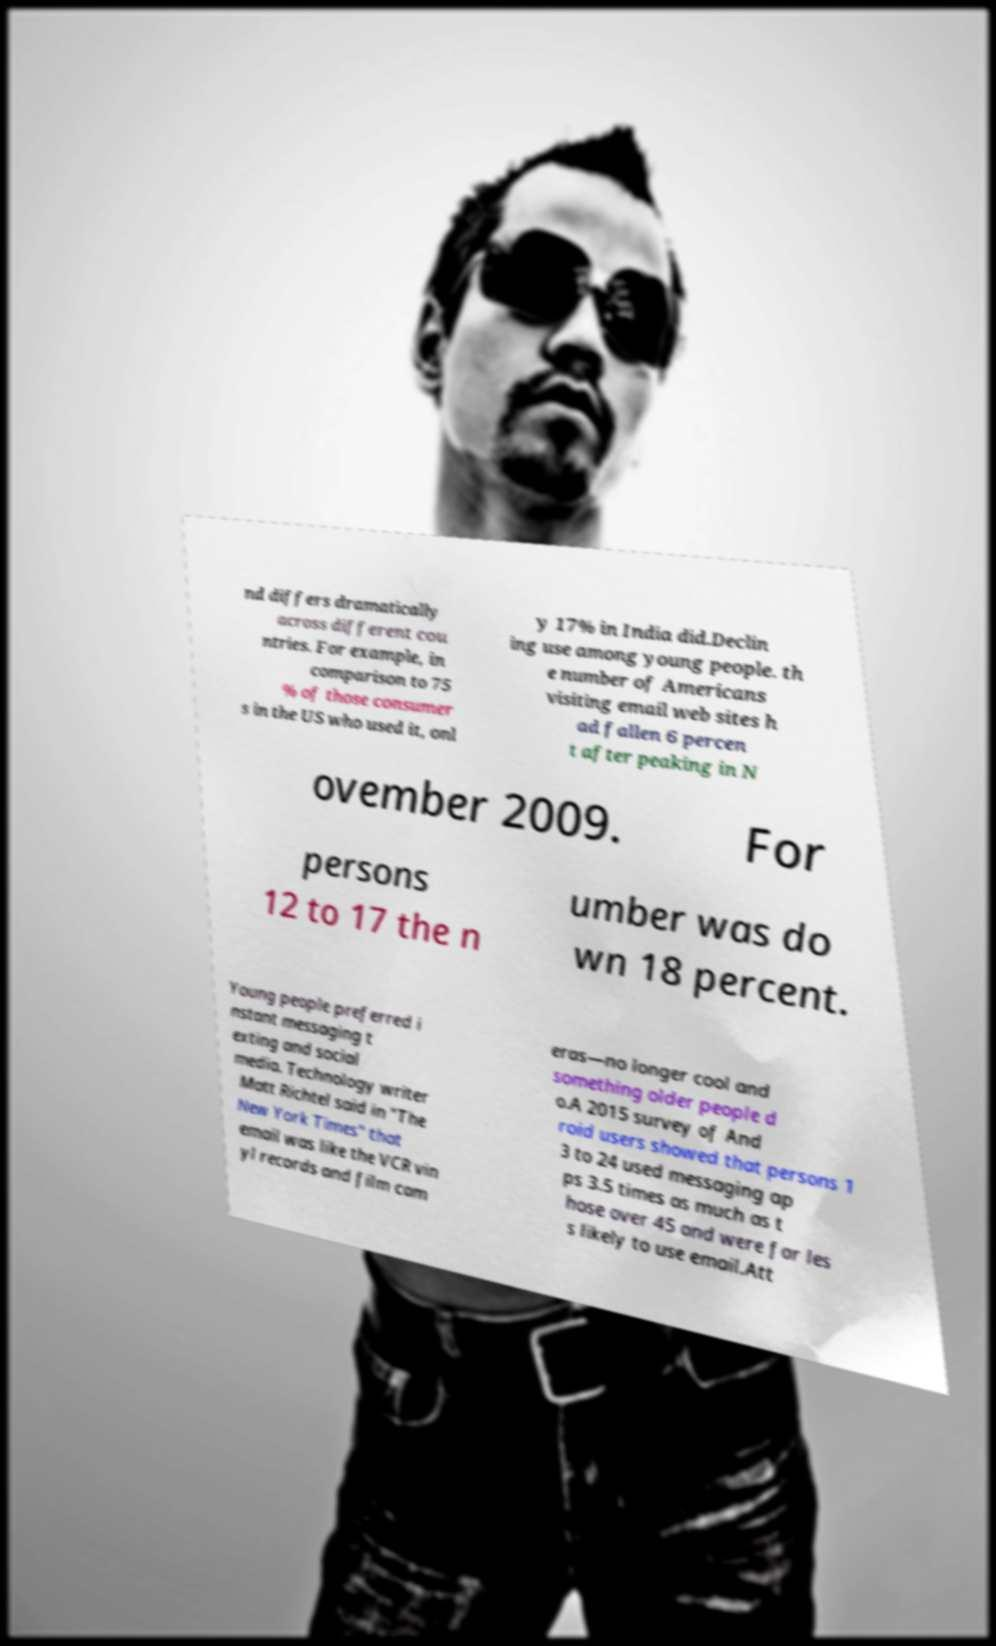Can you read and provide the text displayed in the image?This photo seems to have some interesting text. Can you extract and type it out for me? nd differs dramatically across different cou ntries. For example, in comparison to 75 % of those consumer s in the US who used it, onl y 17% in India did.Declin ing use among young people. th e number of Americans visiting email web sites h ad fallen 6 percen t after peaking in N ovember 2009. For persons 12 to 17 the n umber was do wn 18 percent. Young people preferred i nstant messaging t exting and social media. Technology writer Matt Richtel said in "The New York Times" that email was like the VCR vin yl records and film cam eras—no longer cool and something older people d o.A 2015 survey of And roid users showed that persons 1 3 to 24 used messaging ap ps 3.5 times as much as t hose over 45 and were far les s likely to use email.Att 